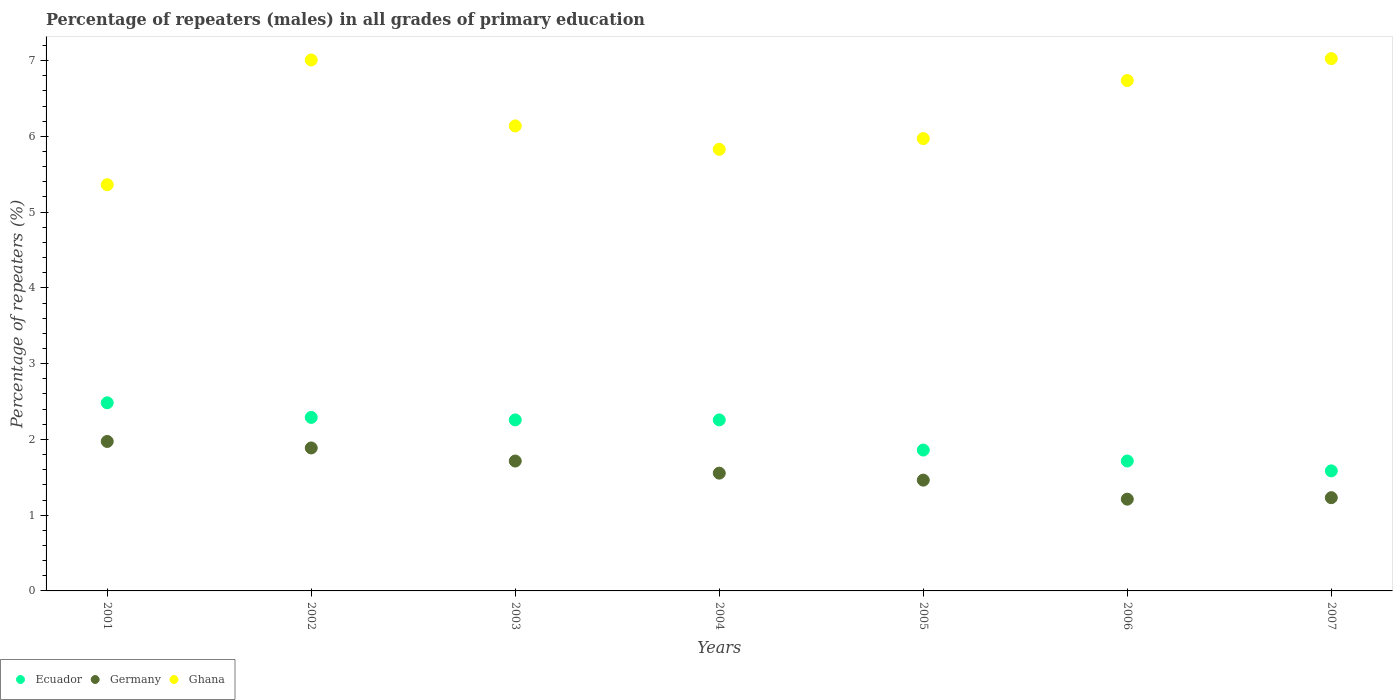Is the number of dotlines equal to the number of legend labels?
Make the answer very short. Yes. What is the percentage of repeaters (males) in Ghana in 2001?
Give a very brief answer. 5.36. Across all years, what is the maximum percentage of repeaters (males) in Germany?
Your answer should be very brief. 1.97. Across all years, what is the minimum percentage of repeaters (males) in Ghana?
Your answer should be very brief. 5.36. What is the total percentage of repeaters (males) in Ghana in the graph?
Make the answer very short. 44.07. What is the difference between the percentage of repeaters (males) in Germany in 2005 and that in 2006?
Your response must be concise. 0.25. What is the difference between the percentage of repeaters (males) in Ghana in 2005 and the percentage of repeaters (males) in Germany in 2001?
Make the answer very short. 4. What is the average percentage of repeaters (males) in Ghana per year?
Your answer should be very brief. 6.3. In the year 2004, what is the difference between the percentage of repeaters (males) in Ghana and percentage of repeaters (males) in Ecuador?
Offer a terse response. 3.57. In how many years, is the percentage of repeaters (males) in Germany greater than 1.6 %?
Provide a short and direct response. 3. What is the ratio of the percentage of repeaters (males) in Ecuador in 2005 to that in 2007?
Your answer should be very brief. 1.17. Is the percentage of repeaters (males) in Germany in 2001 less than that in 2007?
Give a very brief answer. No. Is the difference between the percentage of repeaters (males) in Ghana in 2002 and 2006 greater than the difference between the percentage of repeaters (males) in Ecuador in 2002 and 2006?
Your answer should be compact. No. What is the difference between the highest and the second highest percentage of repeaters (males) in Ghana?
Give a very brief answer. 0.02. What is the difference between the highest and the lowest percentage of repeaters (males) in Germany?
Make the answer very short. 0.76. In how many years, is the percentage of repeaters (males) in Germany greater than the average percentage of repeaters (males) in Germany taken over all years?
Offer a terse response. 3. Is it the case that in every year, the sum of the percentage of repeaters (males) in Ghana and percentage of repeaters (males) in Germany  is greater than the percentage of repeaters (males) in Ecuador?
Make the answer very short. Yes. How many dotlines are there?
Keep it short and to the point. 3. How many years are there in the graph?
Your response must be concise. 7. What is the difference between two consecutive major ticks on the Y-axis?
Your answer should be compact. 1. Are the values on the major ticks of Y-axis written in scientific E-notation?
Your answer should be compact. No. Does the graph contain any zero values?
Provide a short and direct response. No. How many legend labels are there?
Offer a terse response. 3. What is the title of the graph?
Your answer should be compact. Percentage of repeaters (males) in all grades of primary education. What is the label or title of the X-axis?
Make the answer very short. Years. What is the label or title of the Y-axis?
Your answer should be very brief. Percentage of repeaters (%). What is the Percentage of repeaters (%) in Ecuador in 2001?
Ensure brevity in your answer.  2.48. What is the Percentage of repeaters (%) of Germany in 2001?
Ensure brevity in your answer.  1.97. What is the Percentage of repeaters (%) in Ghana in 2001?
Make the answer very short. 5.36. What is the Percentage of repeaters (%) of Ecuador in 2002?
Your response must be concise. 2.29. What is the Percentage of repeaters (%) of Germany in 2002?
Offer a very short reply. 1.89. What is the Percentage of repeaters (%) in Ghana in 2002?
Your answer should be very brief. 7.01. What is the Percentage of repeaters (%) in Ecuador in 2003?
Provide a succinct answer. 2.26. What is the Percentage of repeaters (%) of Germany in 2003?
Offer a terse response. 1.71. What is the Percentage of repeaters (%) in Ghana in 2003?
Provide a short and direct response. 6.14. What is the Percentage of repeaters (%) of Ecuador in 2004?
Provide a short and direct response. 2.26. What is the Percentage of repeaters (%) of Germany in 2004?
Ensure brevity in your answer.  1.55. What is the Percentage of repeaters (%) of Ghana in 2004?
Your answer should be compact. 5.83. What is the Percentage of repeaters (%) in Ecuador in 2005?
Provide a succinct answer. 1.86. What is the Percentage of repeaters (%) of Germany in 2005?
Your response must be concise. 1.46. What is the Percentage of repeaters (%) of Ghana in 2005?
Your answer should be very brief. 5.97. What is the Percentage of repeaters (%) in Ecuador in 2006?
Your response must be concise. 1.71. What is the Percentage of repeaters (%) in Germany in 2006?
Make the answer very short. 1.21. What is the Percentage of repeaters (%) in Ghana in 2006?
Your response must be concise. 6.74. What is the Percentage of repeaters (%) of Ecuador in 2007?
Make the answer very short. 1.58. What is the Percentage of repeaters (%) of Germany in 2007?
Your answer should be compact. 1.23. What is the Percentage of repeaters (%) in Ghana in 2007?
Offer a very short reply. 7.03. Across all years, what is the maximum Percentage of repeaters (%) of Ecuador?
Your answer should be very brief. 2.48. Across all years, what is the maximum Percentage of repeaters (%) of Germany?
Provide a succinct answer. 1.97. Across all years, what is the maximum Percentage of repeaters (%) in Ghana?
Your answer should be very brief. 7.03. Across all years, what is the minimum Percentage of repeaters (%) in Ecuador?
Provide a succinct answer. 1.58. Across all years, what is the minimum Percentage of repeaters (%) of Germany?
Make the answer very short. 1.21. Across all years, what is the minimum Percentage of repeaters (%) in Ghana?
Ensure brevity in your answer.  5.36. What is the total Percentage of repeaters (%) in Ecuador in the graph?
Provide a short and direct response. 14.45. What is the total Percentage of repeaters (%) in Germany in the graph?
Provide a succinct answer. 11.03. What is the total Percentage of repeaters (%) in Ghana in the graph?
Offer a very short reply. 44.07. What is the difference between the Percentage of repeaters (%) of Ecuador in 2001 and that in 2002?
Offer a terse response. 0.19. What is the difference between the Percentage of repeaters (%) of Germany in 2001 and that in 2002?
Make the answer very short. 0.09. What is the difference between the Percentage of repeaters (%) of Ghana in 2001 and that in 2002?
Make the answer very short. -1.65. What is the difference between the Percentage of repeaters (%) in Ecuador in 2001 and that in 2003?
Your response must be concise. 0.23. What is the difference between the Percentage of repeaters (%) of Germany in 2001 and that in 2003?
Your answer should be compact. 0.26. What is the difference between the Percentage of repeaters (%) of Ghana in 2001 and that in 2003?
Give a very brief answer. -0.78. What is the difference between the Percentage of repeaters (%) of Ecuador in 2001 and that in 2004?
Your response must be concise. 0.23. What is the difference between the Percentage of repeaters (%) in Germany in 2001 and that in 2004?
Make the answer very short. 0.42. What is the difference between the Percentage of repeaters (%) of Ghana in 2001 and that in 2004?
Keep it short and to the point. -0.47. What is the difference between the Percentage of repeaters (%) in Ecuador in 2001 and that in 2005?
Provide a succinct answer. 0.62. What is the difference between the Percentage of repeaters (%) in Germany in 2001 and that in 2005?
Your answer should be very brief. 0.51. What is the difference between the Percentage of repeaters (%) in Ghana in 2001 and that in 2005?
Offer a terse response. -0.61. What is the difference between the Percentage of repeaters (%) in Ecuador in 2001 and that in 2006?
Offer a terse response. 0.77. What is the difference between the Percentage of repeaters (%) in Germany in 2001 and that in 2006?
Offer a very short reply. 0.76. What is the difference between the Percentage of repeaters (%) in Ghana in 2001 and that in 2006?
Make the answer very short. -1.37. What is the difference between the Percentage of repeaters (%) in Ecuador in 2001 and that in 2007?
Provide a short and direct response. 0.9. What is the difference between the Percentage of repeaters (%) in Germany in 2001 and that in 2007?
Keep it short and to the point. 0.74. What is the difference between the Percentage of repeaters (%) in Ghana in 2001 and that in 2007?
Offer a very short reply. -1.66. What is the difference between the Percentage of repeaters (%) of Ecuador in 2002 and that in 2003?
Provide a short and direct response. 0.03. What is the difference between the Percentage of repeaters (%) in Germany in 2002 and that in 2003?
Provide a succinct answer. 0.17. What is the difference between the Percentage of repeaters (%) of Ghana in 2002 and that in 2003?
Provide a short and direct response. 0.87. What is the difference between the Percentage of repeaters (%) of Ecuador in 2002 and that in 2004?
Your answer should be very brief. 0.03. What is the difference between the Percentage of repeaters (%) in Germany in 2002 and that in 2004?
Provide a short and direct response. 0.33. What is the difference between the Percentage of repeaters (%) in Ghana in 2002 and that in 2004?
Your answer should be very brief. 1.18. What is the difference between the Percentage of repeaters (%) in Ecuador in 2002 and that in 2005?
Ensure brevity in your answer.  0.43. What is the difference between the Percentage of repeaters (%) of Germany in 2002 and that in 2005?
Your answer should be compact. 0.42. What is the difference between the Percentage of repeaters (%) in Ghana in 2002 and that in 2005?
Provide a succinct answer. 1.04. What is the difference between the Percentage of repeaters (%) of Ecuador in 2002 and that in 2006?
Your answer should be compact. 0.58. What is the difference between the Percentage of repeaters (%) of Germany in 2002 and that in 2006?
Provide a succinct answer. 0.68. What is the difference between the Percentage of repeaters (%) in Ghana in 2002 and that in 2006?
Keep it short and to the point. 0.27. What is the difference between the Percentage of repeaters (%) in Ecuador in 2002 and that in 2007?
Offer a terse response. 0.71. What is the difference between the Percentage of repeaters (%) in Germany in 2002 and that in 2007?
Offer a terse response. 0.66. What is the difference between the Percentage of repeaters (%) of Ghana in 2002 and that in 2007?
Give a very brief answer. -0.02. What is the difference between the Percentage of repeaters (%) in Germany in 2003 and that in 2004?
Give a very brief answer. 0.16. What is the difference between the Percentage of repeaters (%) in Ghana in 2003 and that in 2004?
Ensure brevity in your answer.  0.31. What is the difference between the Percentage of repeaters (%) in Ecuador in 2003 and that in 2005?
Give a very brief answer. 0.4. What is the difference between the Percentage of repeaters (%) of Germany in 2003 and that in 2005?
Make the answer very short. 0.25. What is the difference between the Percentage of repeaters (%) in Ghana in 2003 and that in 2005?
Your response must be concise. 0.17. What is the difference between the Percentage of repeaters (%) of Ecuador in 2003 and that in 2006?
Provide a succinct answer. 0.54. What is the difference between the Percentage of repeaters (%) in Germany in 2003 and that in 2006?
Your answer should be compact. 0.5. What is the difference between the Percentage of repeaters (%) of Ghana in 2003 and that in 2006?
Your answer should be very brief. -0.6. What is the difference between the Percentage of repeaters (%) in Ecuador in 2003 and that in 2007?
Provide a short and direct response. 0.67. What is the difference between the Percentage of repeaters (%) of Germany in 2003 and that in 2007?
Your response must be concise. 0.48. What is the difference between the Percentage of repeaters (%) of Ghana in 2003 and that in 2007?
Keep it short and to the point. -0.89. What is the difference between the Percentage of repeaters (%) of Ecuador in 2004 and that in 2005?
Provide a short and direct response. 0.4. What is the difference between the Percentage of repeaters (%) in Germany in 2004 and that in 2005?
Give a very brief answer. 0.09. What is the difference between the Percentage of repeaters (%) of Ghana in 2004 and that in 2005?
Your response must be concise. -0.14. What is the difference between the Percentage of repeaters (%) of Ecuador in 2004 and that in 2006?
Offer a very short reply. 0.54. What is the difference between the Percentage of repeaters (%) in Germany in 2004 and that in 2006?
Keep it short and to the point. 0.34. What is the difference between the Percentage of repeaters (%) in Ghana in 2004 and that in 2006?
Make the answer very short. -0.91. What is the difference between the Percentage of repeaters (%) of Ecuador in 2004 and that in 2007?
Your response must be concise. 0.67. What is the difference between the Percentage of repeaters (%) of Germany in 2004 and that in 2007?
Offer a very short reply. 0.32. What is the difference between the Percentage of repeaters (%) in Ghana in 2004 and that in 2007?
Keep it short and to the point. -1.2. What is the difference between the Percentage of repeaters (%) in Ecuador in 2005 and that in 2006?
Give a very brief answer. 0.14. What is the difference between the Percentage of repeaters (%) in Germany in 2005 and that in 2006?
Keep it short and to the point. 0.25. What is the difference between the Percentage of repeaters (%) of Ghana in 2005 and that in 2006?
Your answer should be very brief. -0.77. What is the difference between the Percentage of repeaters (%) in Ecuador in 2005 and that in 2007?
Offer a terse response. 0.27. What is the difference between the Percentage of repeaters (%) of Germany in 2005 and that in 2007?
Make the answer very short. 0.23. What is the difference between the Percentage of repeaters (%) of Ghana in 2005 and that in 2007?
Offer a terse response. -1.06. What is the difference between the Percentage of repeaters (%) in Ecuador in 2006 and that in 2007?
Your answer should be compact. 0.13. What is the difference between the Percentage of repeaters (%) in Germany in 2006 and that in 2007?
Your answer should be very brief. -0.02. What is the difference between the Percentage of repeaters (%) of Ghana in 2006 and that in 2007?
Your response must be concise. -0.29. What is the difference between the Percentage of repeaters (%) in Ecuador in 2001 and the Percentage of repeaters (%) in Germany in 2002?
Ensure brevity in your answer.  0.6. What is the difference between the Percentage of repeaters (%) in Ecuador in 2001 and the Percentage of repeaters (%) in Ghana in 2002?
Provide a succinct answer. -4.53. What is the difference between the Percentage of repeaters (%) in Germany in 2001 and the Percentage of repeaters (%) in Ghana in 2002?
Give a very brief answer. -5.04. What is the difference between the Percentage of repeaters (%) in Ecuador in 2001 and the Percentage of repeaters (%) in Germany in 2003?
Keep it short and to the point. 0.77. What is the difference between the Percentage of repeaters (%) in Ecuador in 2001 and the Percentage of repeaters (%) in Ghana in 2003?
Provide a short and direct response. -3.65. What is the difference between the Percentage of repeaters (%) in Germany in 2001 and the Percentage of repeaters (%) in Ghana in 2003?
Ensure brevity in your answer.  -4.16. What is the difference between the Percentage of repeaters (%) in Ecuador in 2001 and the Percentage of repeaters (%) in Germany in 2004?
Keep it short and to the point. 0.93. What is the difference between the Percentage of repeaters (%) of Ecuador in 2001 and the Percentage of repeaters (%) of Ghana in 2004?
Your answer should be compact. -3.35. What is the difference between the Percentage of repeaters (%) of Germany in 2001 and the Percentage of repeaters (%) of Ghana in 2004?
Offer a very short reply. -3.86. What is the difference between the Percentage of repeaters (%) in Ecuador in 2001 and the Percentage of repeaters (%) in Germany in 2005?
Make the answer very short. 1.02. What is the difference between the Percentage of repeaters (%) of Ecuador in 2001 and the Percentage of repeaters (%) of Ghana in 2005?
Offer a terse response. -3.49. What is the difference between the Percentage of repeaters (%) in Germany in 2001 and the Percentage of repeaters (%) in Ghana in 2005?
Your answer should be compact. -4. What is the difference between the Percentage of repeaters (%) in Ecuador in 2001 and the Percentage of repeaters (%) in Germany in 2006?
Offer a terse response. 1.27. What is the difference between the Percentage of repeaters (%) of Ecuador in 2001 and the Percentage of repeaters (%) of Ghana in 2006?
Give a very brief answer. -4.25. What is the difference between the Percentage of repeaters (%) of Germany in 2001 and the Percentage of repeaters (%) of Ghana in 2006?
Provide a succinct answer. -4.76. What is the difference between the Percentage of repeaters (%) of Ecuador in 2001 and the Percentage of repeaters (%) of Germany in 2007?
Keep it short and to the point. 1.25. What is the difference between the Percentage of repeaters (%) in Ecuador in 2001 and the Percentage of repeaters (%) in Ghana in 2007?
Offer a very short reply. -4.54. What is the difference between the Percentage of repeaters (%) of Germany in 2001 and the Percentage of repeaters (%) of Ghana in 2007?
Make the answer very short. -5.05. What is the difference between the Percentage of repeaters (%) of Ecuador in 2002 and the Percentage of repeaters (%) of Germany in 2003?
Your answer should be compact. 0.58. What is the difference between the Percentage of repeaters (%) of Ecuador in 2002 and the Percentage of repeaters (%) of Ghana in 2003?
Your answer should be compact. -3.85. What is the difference between the Percentage of repeaters (%) of Germany in 2002 and the Percentage of repeaters (%) of Ghana in 2003?
Provide a succinct answer. -4.25. What is the difference between the Percentage of repeaters (%) in Ecuador in 2002 and the Percentage of repeaters (%) in Germany in 2004?
Give a very brief answer. 0.74. What is the difference between the Percentage of repeaters (%) in Ecuador in 2002 and the Percentage of repeaters (%) in Ghana in 2004?
Your answer should be very brief. -3.54. What is the difference between the Percentage of repeaters (%) in Germany in 2002 and the Percentage of repeaters (%) in Ghana in 2004?
Give a very brief answer. -3.94. What is the difference between the Percentage of repeaters (%) of Ecuador in 2002 and the Percentage of repeaters (%) of Germany in 2005?
Ensure brevity in your answer.  0.83. What is the difference between the Percentage of repeaters (%) in Ecuador in 2002 and the Percentage of repeaters (%) in Ghana in 2005?
Provide a succinct answer. -3.68. What is the difference between the Percentage of repeaters (%) of Germany in 2002 and the Percentage of repeaters (%) of Ghana in 2005?
Your response must be concise. -4.08. What is the difference between the Percentage of repeaters (%) in Ecuador in 2002 and the Percentage of repeaters (%) in Germany in 2006?
Your response must be concise. 1.08. What is the difference between the Percentage of repeaters (%) of Ecuador in 2002 and the Percentage of repeaters (%) of Ghana in 2006?
Your answer should be compact. -4.45. What is the difference between the Percentage of repeaters (%) of Germany in 2002 and the Percentage of repeaters (%) of Ghana in 2006?
Provide a succinct answer. -4.85. What is the difference between the Percentage of repeaters (%) of Ecuador in 2002 and the Percentage of repeaters (%) of Germany in 2007?
Provide a short and direct response. 1.06. What is the difference between the Percentage of repeaters (%) in Ecuador in 2002 and the Percentage of repeaters (%) in Ghana in 2007?
Keep it short and to the point. -4.74. What is the difference between the Percentage of repeaters (%) of Germany in 2002 and the Percentage of repeaters (%) of Ghana in 2007?
Provide a succinct answer. -5.14. What is the difference between the Percentage of repeaters (%) in Ecuador in 2003 and the Percentage of repeaters (%) in Germany in 2004?
Provide a succinct answer. 0.7. What is the difference between the Percentage of repeaters (%) in Ecuador in 2003 and the Percentage of repeaters (%) in Ghana in 2004?
Keep it short and to the point. -3.57. What is the difference between the Percentage of repeaters (%) in Germany in 2003 and the Percentage of repeaters (%) in Ghana in 2004?
Your answer should be very brief. -4.11. What is the difference between the Percentage of repeaters (%) of Ecuador in 2003 and the Percentage of repeaters (%) of Germany in 2005?
Keep it short and to the point. 0.8. What is the difference between the Percentage of repeaters (%) in Ecuador in 2003 and the Percentage of repeaters (%) in Ghana in 2005?
Keep it short and to the point. -3.71. What is the difference between the Percentage of repeaters (%) in Germany in 2003 and the Percentage of repeaters (%) in Ghana in 2005?
Your answer should be compact. -4.26. What is the difference between the Percentage of repeaters (%) in Ecuador in 2003 and the Percentage of repeaters (%) in Germany in 2006?
Offer a very short reply. 1.05. What is the difference between the Percentage of repeaters (%) in Ecuador in 2003 and the Percentage of repeaters (%) in Ghana in 2006?
Provide a short and direct response. -4.48. What is the difference between the Percentage of repeaters (%) of Germany in 2003 and the Percentage of repeaters (%) of Ghana in 2006?
Give a very brief answer. -5.02. What is the difference between the Percentage of repeaters (%) in Ecuador in 2003 and the Percentage of repeaters (%) in Germany in 2007?
Offer a terse response. 1.03. What is the difference between the Percentage of repeaters (%) in Ecuador in 2003 and the Percentage of repeaters (%) in Ghana in 2007?
Ensure brevity in your answer.  -4.77. What is the difference between the Percentage of repeaters (%) of Germany in 2003 and the Percentage of repeaters (%) of Ghana in 2007?
Offer a terse response. -5.31. What is the difference between the Percentage of repeaters (%) in Ecuador in 2004 and the Percentage of repeaters (%) in Germany in 2005?
Provide a succinct answer. 0.79. What is the difference between the Percentage of repeaters (%) of Ecuador in 2004 and the Percentage of repeaters (%) of Ghana in 2005?
Your response must be concise. -3.71. What is the difference between the Percentage of repeaters (%) of Germany in 2004 and the Percentage of repeaters (%) of Ghana in 2005?
Your response must be concise. -4.42. What is the difference between the Percentage of repeaters (%) of Ecuador in 2004 and the Percentage of repeaters (%) of Germany in 2006?
Offer a terse response. 1.05. What is the difference between the Percentage of repeaters (%) in Ecuador in 2004 and the Percentage of repeaters (%) in Ghana in 2006?
Offer a very short reply. -4.48. What is the difference between the Percentage of repeaters (%) of Germany in 2004 and the Percentage of repeaters (%) of Ghana in 2006?
Your answer should be compact. -5.18. What is the difference between the Percentage of repeaters (%) of Ecuador in 2004 and the Percentage of repeaters (%) of Germany in 2007?
Provide a short and direct response. 1.03. What is the difference between the Percentage of repeaters (%) in Ecuador in 2004 and the Percentage of repeaters (%) in Ghana in 2007?
Provide a short and direct response. -4.77. What is the difference between the Percentage of repeaters (%) of Germany in 2004 and the Percentage of repeaters (%) of Ghana in 2007?
Provide a short and direct response. -5.47. What is the difference between the Percentage of repeaters (%) of Ecuador in 2005 and the Percentage of repeaters (%) of Germany in 2006?
Your answer should be compact. 0.65. What is the difference between the Percentage of repeaters (%) of Ecuador in 2005 and the Percentage of repeaters (%) of Ghana in 2006?
Your answer should be very brief. -4.88. What is the difference between the Percentage of repeaters (%) of Germany in 2005 and the Percentage of repeaters (%) of Ghana in 2006?
Keep it short and to the point. -5.27. What is the difference between the Percentage of repeaters (%) of Ecuador in 2005 and the Percentage of repeaters (%) of Germany in 2007?
Make the answer very short. 0.63. What is the difference between the Percentage of repeaters (%) of Ecuador in 2005 and the Percentage of repeaters (%) of Ghana in 2007?
Your response must be concise. -5.17. What is the difference between the Percentage of repeaters (%) in Germany in 2005 and the Percentage of repeaters (%) in Ghana in 2007?
Your answer should be compact. -5.56. What is the difference between the Percentage of repeaters (%) of Ecuador in 2006 and the Percentage of repeaters (%) of Germany in 2007?
Make the answer very short. 0.48. What is the difference between the Percentage of repeaters (%) of Ecuador in 2006 and the Percentage of repeaters (%) of Ghana in 2007?
Your answer should be compact. -5.31. What is the difference between the Percentage of repeaters (%) of Germany in 2006 and the Percentage of repeaters (%) of Ghana in 2007?
Make the answer very short. -5.82. What is the average Percentage of repeaters (%) in Ecuador per year?
Keep it short and to the point. 2.06. What is the average Percentage of repeaters (%) of Germany per year?
Your answer should be very brief. 1.58. What is the average Percentage of repeaters (%) in Ghana per year?
Offer a very short reply. 6.3. In the year 2001, what is the difference between the Percentage of repeaters (%) of Ecuador and Percentage of repeaters (%) of Germany?
Keep it short and to the point. 0.51. In the year 2001, what is the difference between the Percentage of repeaters (%) of Ecuador and Percentage of repeaters (%) of Ghana?
Your response must be concise. -2.88. In the year 2001, what is the difference between the Percentage of repeaters (%) in Germany and Percentage of repeaters (%) in Ghana?
Your answer should be very brief. -3.39. In the year 2002, what is the difference between the Percentage of repeaters (%) of Ecuador and Percentage of repeaters (%) of Germany?
Provide a short and direct response. 0.4. In the year 2002, what is the difference between the Percentage of repeaters (%) in Ecuador and Percentage of repeaters (%) in Ghana?
Ensure brevity in your answer.  -4.72. In the year 2002, what is the difference between the Percentage of repeaters (%) in Germany and Percentage of repeaters (%) in Ghana?
Provide a succinct answer. -5.12. In the year 2003, what is the difference between the Percentage of repeaters (%) of Ecuador and Percentage of repeaters (%) of Germany?
Your response must be concise. 0.54. In the year 2003, what is the difference between the Percentage of repeaters (%) in Ecuador and Percentage of repeaters (%) in Ghana?
Your response must be concise. -3.88. In the year 2003, what is the difference between the Percentage of repeaters (%) of Germany and Percentage of repeaters (%) of Ghana?
Your response must be concise. -4.42. In the year 2004, what is the difference between the Percentage of repeaters (%) of Ecuador and Percentage of repeaters (%) of Germany?
Provide a short and direct response. 0.7. In the year 2004, what is the difference between the Percentage of repeaters (%) in Ecuador and Percentage of repeaters (%) in Ghana?
Offer a terse response. -3.57. In the year 2004, what is the difference between the Percentage of repeaters (%) in Germany and Percentage of repeaters (%) in Ghana?
Provide a succinct answer. -4.27. In the year 2005, what is the difference between the Percentage of repeaters (%) in Ecuador and Percentage of repeaters (%) in Germany?
Offer a very short reply. 0.4. In the year 2005, what is the difference between the Percentage of repeaters (%) of Ecuador and Percentage of repeaters (%) of Ghana?
Make the answer very short. -4.11. In the year 2005, what is the difference between the Percentage of repeaters (%) of Germany and Percentage of repeaters (%) of Ghana?
Keep it short and to the point. -4.51. In the year 2006, what is the difference between the Percentage of repeaters (%) in Ecuador and Percentage of repeaters (%) in Germany?
Provide a short and direct response. 0.5. In the year 2006, what is the difference between the Percentage of repeaters (%) of Ecuador and Percentage of repeaters (%) of Ghana?
Your response must be concise. -5.02. In the year 2006, what is the difference between the Percentage of repeaters (%) in Germany and Percentage of repeaters (%) in Ghana?
Your answer should be very brief. -5.53. In the year 2007, what is the difference between the Percentage of repeaters (%) of Ecuador and Percentage of repeaters (%) of Germany?
Provide a succinct answer. 0.35. In the year 2007, what is the difference between the Percentage of repeaters (%) in Ecuador and Percentage of repeaters (%) in Ghana?
Provide a succinct answer. -5.44. In the year 2007, what is the difference between the Percentage of repeaters (%) of Germany and Percentage of repeaters (%) of Ghana?
Keep it short and to the point. -5.8. What is the ratio of the Percentage of repeaters (%) of Ecuador in 2001 to that in 2002?
Your answer should be very brief. 1.08. What is the ratio of the Percentage of repeaters (%) in Germany in 2001 to that in 2002?
Give a very brief answer. 1.05. What is the ratio of the Percentage of repeaters (%) in Ghana in 2001 to that in 2002?
Make the answer very short. 0.77. What is the ratio of the Percentage of repeaters (%) of Ecuador in 2001 to that in 2003?
Offer a very short reply. 1.1. What is the ratio of the Percentage of repeaters (%) in Germany in 2001 to that in 2003?
Your response must be concise. 1.15. What is the ratio of the Percentage of repeaters (%) of Ghana in 2001 to that in 2003?
Provide a short and direct response. 0.87. What is the ratio of the Percentage of repeaters (%) in Ecuador in 2001 to that in 2004?
Provide a short and direct response. 1.1. What is the ratio of the Percentage of repeaters (%) of Germany in 2001 to that in 2004?
Ensure brevity in your answer.  1.27. What is the ratio of the Percentage of repeaters (%) in Ghana in 2001 to that in 2004?
Ensure brevity in your answer.  0.92. What is the ratio of the Percentage of repeaters (%) of Ecuador in 2001 to that in 2005?
Offer a terse response. 1.34. What is the ratio of the Percentage of repeaters (%) of Germany in 2001 to that in 2005?
Ensure brevity in your answer.  1.35. What is the ratio of the Percentage of repeaters (%) in Ghana in 2001 to that in 2005?
Make the answer very short. 0.9. What is the ratio of the Percentage of repeaters (%) in Ecuador in 2001 to that in 2006?
Offer a terse response. 1.45. What is the ratio of the Percentage of repeaters (%) of Germany in 2001 to that in 2006?
Provide a short and direct response. 1.63. What is the ratio of the Percentage of repeaters (%) in Ghana in 2001 to that in 2006?
Ensure brevity in your answer.  0.8. What is the ratio of the Percentage of repeaters (%) of Ecuador in 2001 to that in 2007?
Your response must be concise. 1.57. What is the ratio of the Percentage of repeaters (%) in Germany in 2001 to that in 2007?
Provide a succinct answer. 1.6. What is the ratio of the Percentage of repeaters (%) of Ghana in 2001 to that in 2007?
Ensure brevity in your answer.  0.76. What is the ratio of the Percentage of repeaters (%) of Ecuador in 2002 to that in 2003?
Keep it short and to the point. 1.01. What is the ratio of the Percentage of repeaters (%) of Germany in 2002 to that in 2003?
Provide a succinct answer. 1.1. What is the ratio of the Percentage of repeaters (%) of Ghana in 2002 to that in 2003?
Keep it short and to the point. 1.14. What is the ratio of the Percentage of repeaters (%) of Ecuador in 2002 to that in 2004?
Give a very brief answer. 1.01. What is the ratio of the Percentage of repeaters (%) of Germany in 2002 to that in 2004?
Your answer should be very brief. 1.21. What is the ratio of the Percentage of repeaters (%) of Ghana in 2002 to that in 2004?
Offer a very short reply. 1.2. What is the ratio of the Percentage of repeaters (%) in Ecuador in 2002 to that in 2005?
Your answer should be compact. 1.23. What is the ratio of the Percentage of repeaters (%) in Germany in 2002 to that in 2005?
Your answer should be compact. 1.29. What is the ratio of the Percentage of repeaters (%) in Ghana in 2002 to that in 2005?
Keep it short and to the point. 1.17. What is the ratio of the Percentage of repeaters (%) in Ecuador in 2002 to that in 2006?
Offer a very short reply. 1.34. What is the ratio of the Percentage of repeaters (%) in Germany in 2002 to that in 2006?
Offer a very short reply. 1.56. What is the ratio of the Percentage of repeaters (%) of Ghana in 2002 to that in 2006?
Provide a succinct answer. 1.04. What is the ratio of the Percentage of repeaters (%) of Ecuador in 2002 to that in 2007?
Your answer should be very brief. 1.45. What is the ratio of the Percentage of repeaters (%) in Germany in 2002 to that in 2007?
Provide a short and direct response. 1.53. What is the ratio of the Percentage of repeaters (%) of Germany in 2003 to that in 2004?
Provide a succinct answer. 1.1. What is the ratio of the Percentage of repeaters (%) in Ghana in 2003 to that in 2004?
Keep it short and to the point. 1.05. What is the ratio of the Percentage of repeaters (%) of Ecuador in 2003 to that in 2005?
Your response must be concise. 1.21. What is the ratio of the Percentage of repeaters (%) in Germany in 2003 to that in 2005?
Your answer should be very brief. 1.17. What is the ratio of the Percentage of repeaters (%) of Ghana in 2003 to that in 2005?
Ensure brevity in your answer.  1.03. What is the ratio of the Percentage of repeaters (%) in Ecuador in 2003 to that in 2006?
Offer a terse response. 1.32. What is the ratio of the Percentage of repeaters (%) in Germany in 2003 to that in 2006?
Offer a very short reply. 1.42. What is the ratio of the Percentage of repeaters (%) of Ghana in 2003 to that in 2006?
Your answer should be very brief. 0.91. What is the ratio of the Percentage of repeaters (%) of Ecuador in 2003 to that in 2007?
Keep it short and to the point. 1.42. What is the ratio of the Percentage of repeaters (%) in Germany in 2003 to that in 2007?
Ensure brevity in your answer.  1.39. What is the ratio of the Percentage of repeaters (%) in Ghana in 2003 to that in 2007?
Your answer should be very brief. 0.87. What is the ratio of the Percentage of repeaters (%) in Ecuador in 2004 to that in 2005?
Give a very brief answer. 1.21. What is the ratio of the Percentage of repeaters (%) in Germany in 2004 to that in 2005?
Offer a very short reply. 1.06. What is the ratio of the Percentage of repeaters (%) in Ghana in 2004 to that in 2005?
Your answer should be very brief. 0.98. What is the ratio of the Percentage of repeaters (%) in Ecuador in 2004 to that in 2006?
Offer a terse response. 1.32. What is the ratio of the Percentage of repeaters (%) of Germany in 2004 to that in 2006?
Keep it short and to the point. 1.28. What is the ratio of the Percentage of repeaters (%) in Ghana in 2004 to that in 2006?
Make the answer very short. 0.87. What is the ratio of the Percentage of repeaters (%) in Ecuador in 2004 to that in 2007?
Your answer should be compact. 1.42. What is the ratio of the Percentage of repeaters (%) in Germany in 2004 to that in 2007?
Your response must be concise. 1.26. What is the ratio of the Percentage of repeaters (%) in Ghana in 2004 to that in 2007?
Provide a short and direct response. 0.83. What is the ratio of the Percentage of repeaters (%) of Ecuador in 2005 to that in 2006?
Your answer should be compact. 1.08. What is the ratio of the Percentage of repeaters (%) in Germany in 2005 to that in 2006?
Your answer should be very brief. 1.21. What is the ratio of the Percentage of repeaters (%) in Ghana in 2005 to that in 2006?
Offer a terse response. 0.89. What is the ratio of the Percentage of repeaters (%) of Ecuador in 2005 to that in 2007?
Your answer should be compact. 1.17. What is the ratio of the Percentage of repeaters (%) in Germany in 2005 to that in 2007?
Your response must be concise. 1.19. What is the ratio of the Percentage of repeaters (%) in Ghana in 2005 to that in 2007?
Your answer should be compact. 0.85. What is the ratio of the Percentage of repeaters (%) of Ecuador in 2006 to that in 2007?
Keep it short and to the point. 1.08. What is the ratio of the Percentage of repeaters (%) of Germany in 2006 to that in 2007?
Give a very brief answer. 0.98. What is the ratio of the Percentage of repeaters (%) of Ghana in 2006 to that in 2007?
Keep it short and to the point. 0.96. What is the difference between the highest and the second highest Percentage of repeaters (%) in Ecuador?
Your answer should be very brief. 0.19. What is the difference between the highest and the second highest Percentage of repeaters (%) of Germany?
Offer a terse response. 0.09. What is the difference between the highest and the second highest Percentage of repeaters (%) of Ghana?
Your response must be concise. 0.02. What is the difference between the highest and the lowest Percentage of repeaters (%) in Ecuador?
Offer a terse response. 0.9. What is the difference between the highest and the lowest Percentage of repeaters (%) in Germany?
Provide a short and direct response. 0.76. What is the difference between the highest and the lowest Percentage of repeaters (%) in Ghana?
Provide a succinct answer. 1.66. 